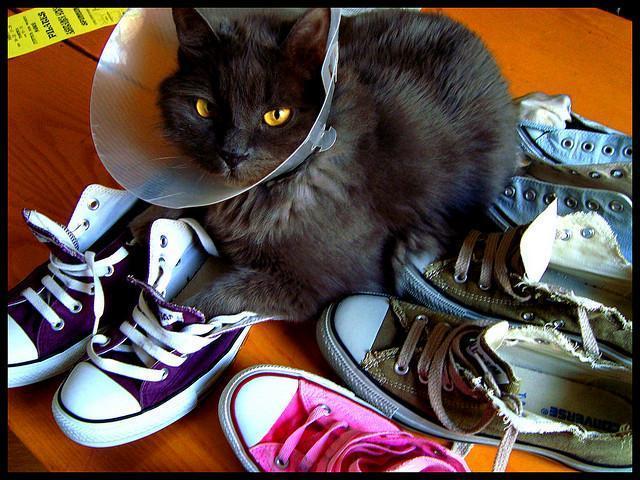How many sneakers are there?
Give a very brief answer. 7. How many large giraffes are there?
Give a very brief answer. 0. 